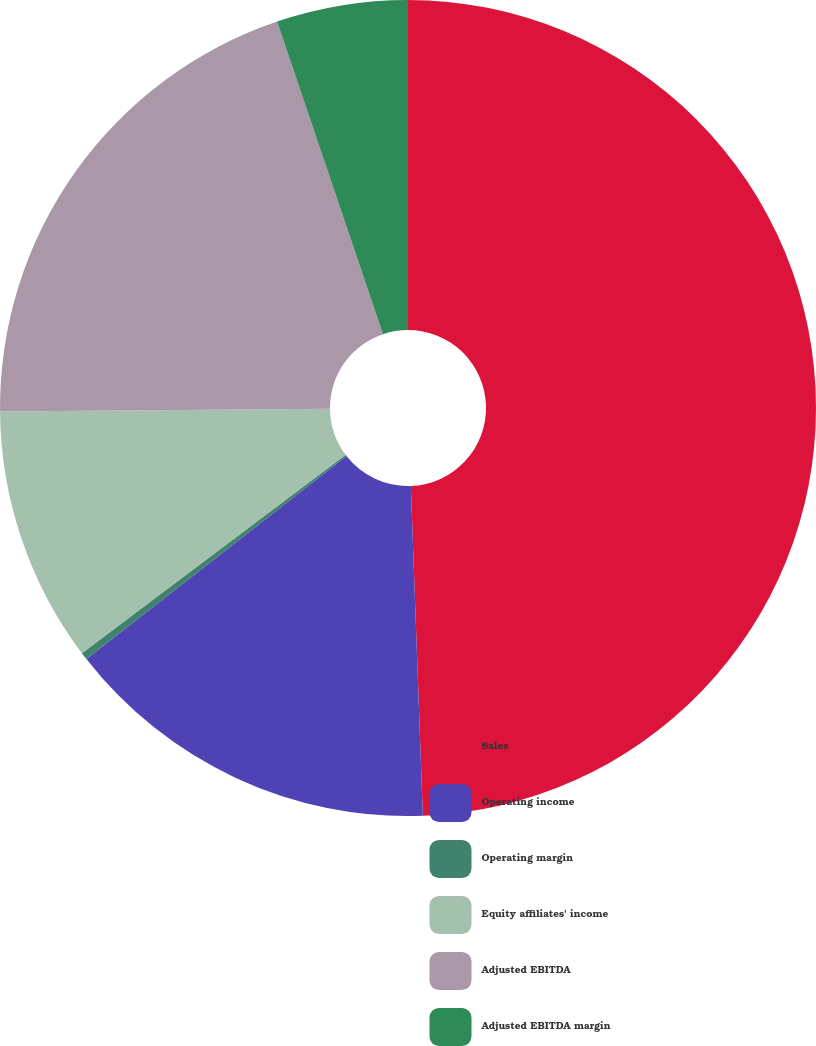Convert chart to OTSL. <chart><loc_0><loc_0><loc_500><loc_500><pie_chart><fcel>Sales<fcel>Operating income<fcel>Operating margin<fcel>Equity affiliates' income<fcel>Adjusted EBITDA<fcel>Adjusted EBITDA margin<nl><fcel>49.42%<fcel>15.03%<fcel>0.29%<fcel>10.12%<fcel>19.94%<fcel>5.2%<nl></chart> 